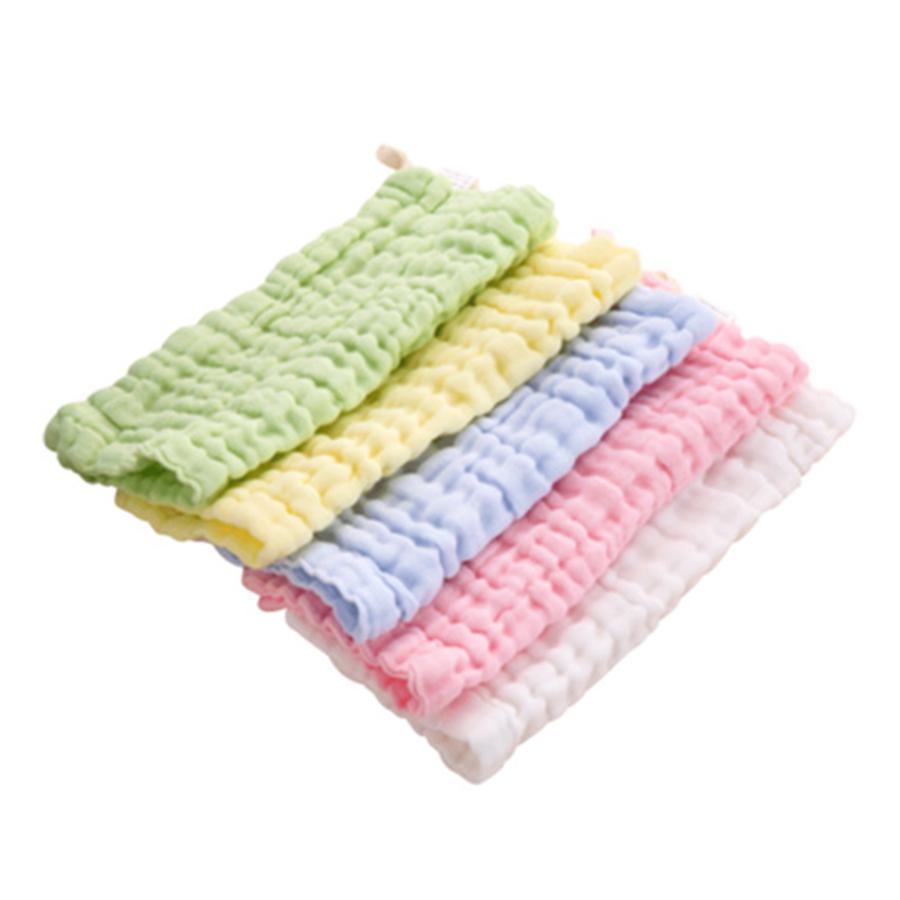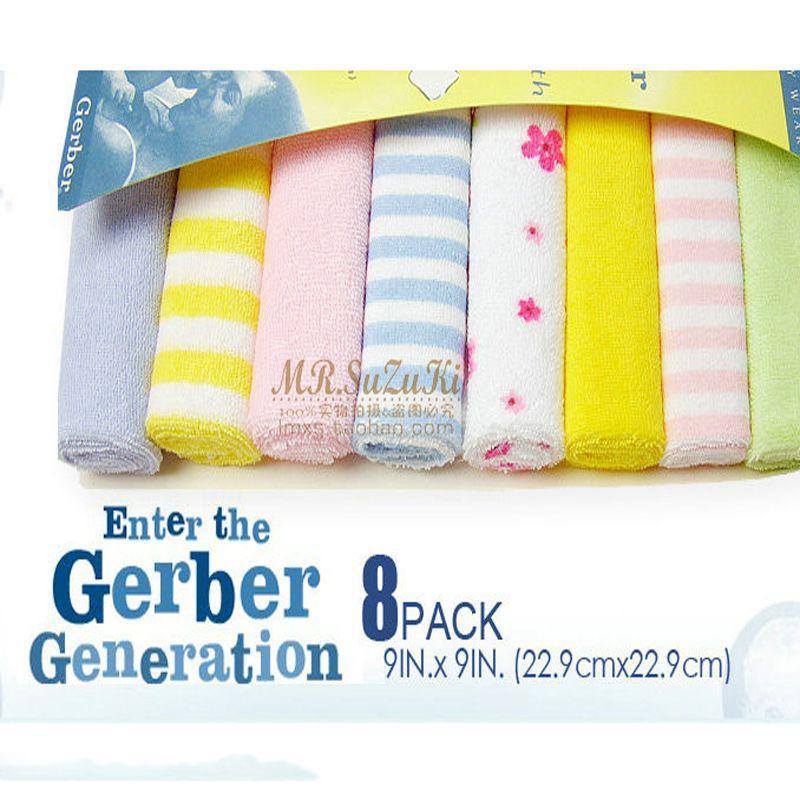The first image is the image on the left, the second image is the image on the right. Considering the images on both sides, is "Each image includes at least one row of folded cloth items, and one image features a package of eight rolled towels." valid? Answer yes or no. Yes. The first image is the image on the left, the second image is the image on the right. For the images displayed, is the sentence "There are exactly eight rolled towels." factually correct? Answer yes or no. Yes. 